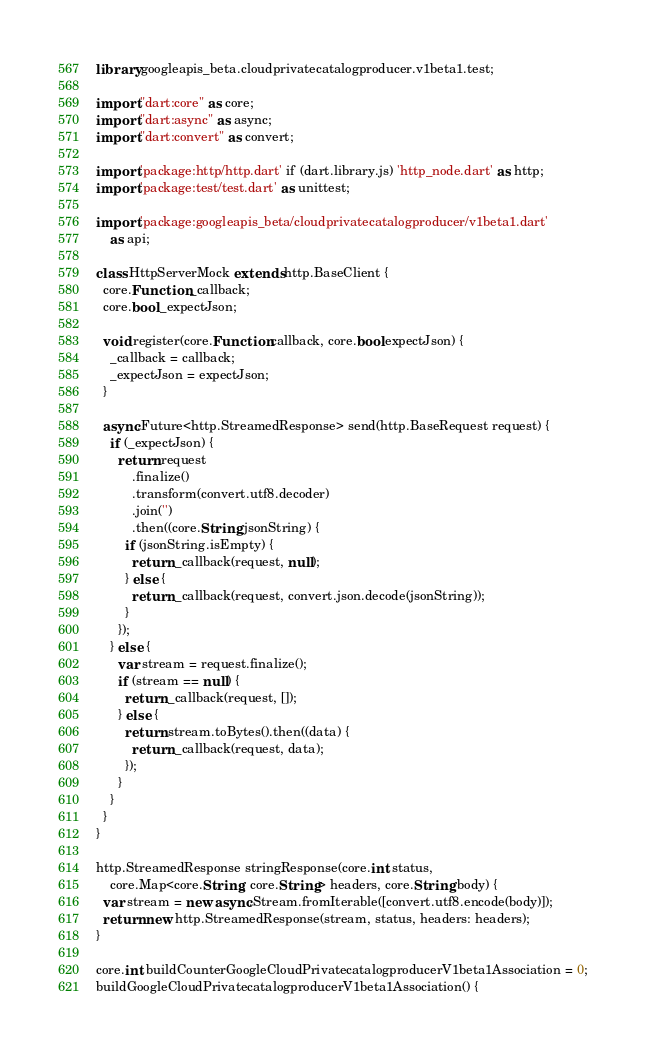Convert code to text. <code><loc_0><loc_0><loc_500><loc_500><_Dart_>library googleapis_beta.cloudprivatecatalogproducer.v1beta1.test;

import "dart:core" as core;
import "dart:async" as async;
import "dart:convert" as convert;

import 'package:http/http.dart' if (dart.library.js) 'http_node.dart' as http;
import 'package:test/test.dart' as unittest;

import 'package:googleapis_beta/cloudprivatecatalogproducer/v1beta1.dart'
    as api;

class HttpServerMock extends http.BaseClient {
  core.Function _callback;
  core.bool _expectJson;

  void register(core.Function callback, core.bool expectJson) {
    _callback = callback;
    _expectJson = expectJson;
  }

  async.Future<http.StreamedResponse> send(http.BaseRequest request) {
    if (_expectJson) {
      return request
          .finalize()
          .transform(convert.utf8.decoder)
          .join('')
          .then((core.String jsonString) {
        if (jsonString.isEmpty) {
          return _callback(request, null);
        } else {
          return _callback(request, convert.json.decode(jsonString));
        }
      });
    } else {
      var stream = request.finalize();
      if (stream == null) {
        return _callback(request, []);
      } else {
        return stream.toBytes().then((data) {
          return _callback(request, data);
        });
      }
    }
  }
}

http.StreamedResponse stringResponse(core.int status,
    core.Map<core.String, core.String> headers, core.String body) {
  var stream = new async.Stream.fromIterable([convert.utf8.encode(body)]);
  return new http.StreamedResponse(stream, status, headers: headers);
}

core.int buildCounterGoogleCloudPrivatecatalogproducerV1beta1Association = 0;
buildGoogleCloudPrivatecatalogproducerV1beta1Association() {</code> 